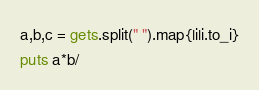Convert code to text. <code><loc_0><loc_0><loc_500><loc_500><_Ruby_>a,b,c = gets.split(" ").map{|i|i.to_i}
puts a*b/</code> 